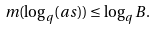<formula> <loc_0><loc_0><loc_500><loc_500>m ( \log _ { q } ( a s ) ) \leq \log _ { q } B .</formula> 